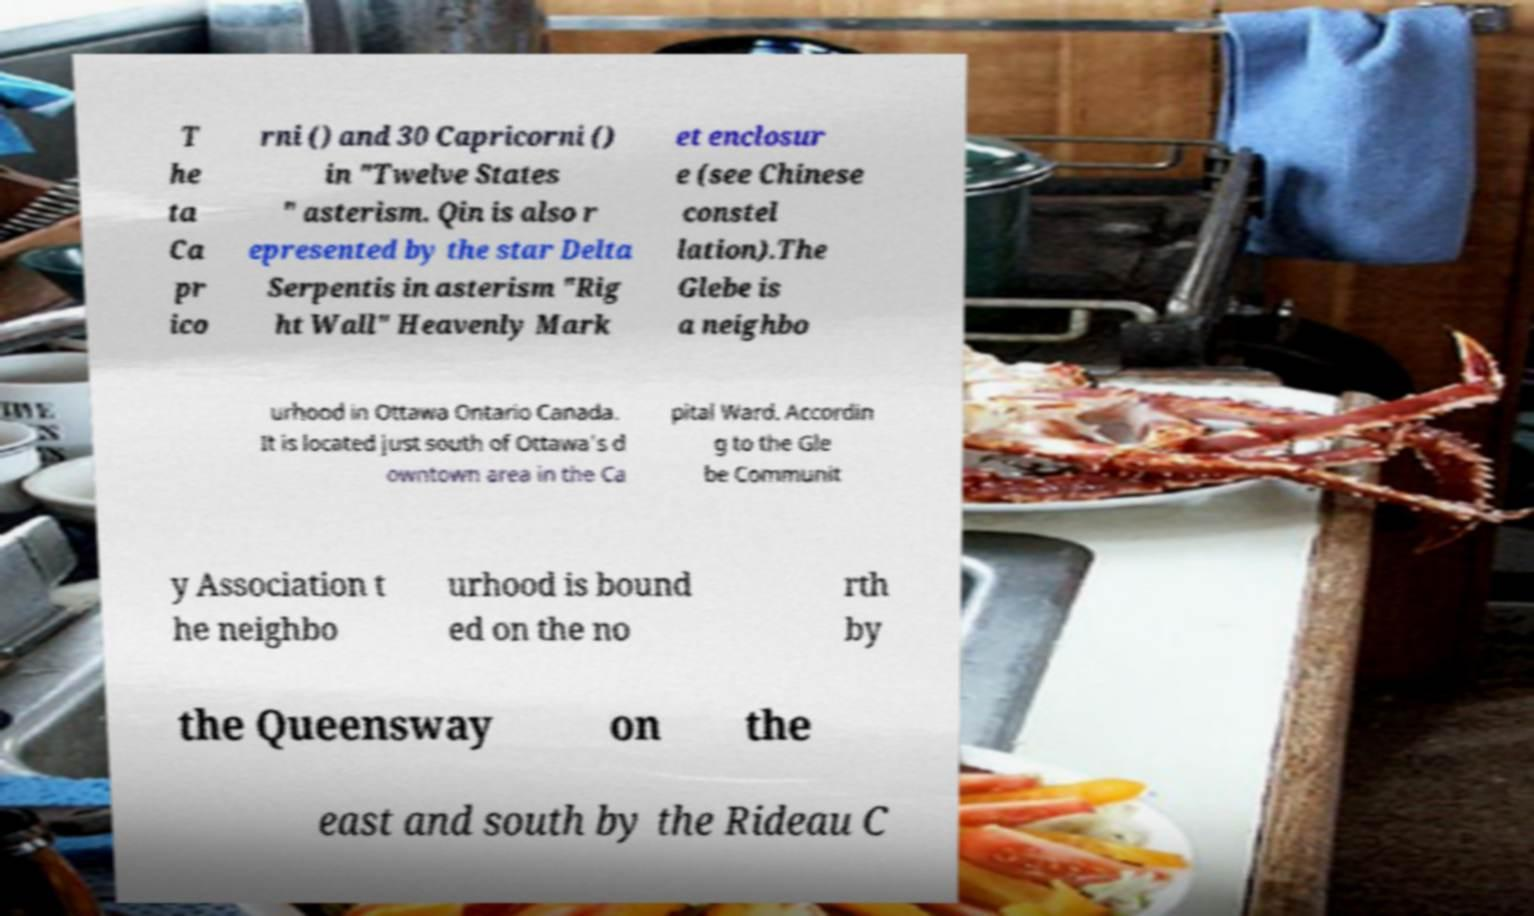Please read and relay the text visible in this image. What does it say? T he ta Ca pr ico rni () and 30 Capricorni () in "Twelve States " asterism. Qin is also r epresented by the star Delta Serpentis in asterism "Rig ht Wall" Heavenly Mark et enclosur e (see Chinese constel lation).The Glebe is a neighbo urhood in Ottawa Ontario Canada. It is located just south of Ottawa's d owntown area in the Ca pital Ward. Accordin g to the Gle be Communit y Association t he neighbo urhood is bound ed on the no rth by the Queensway on the east and south by the Rideau C 